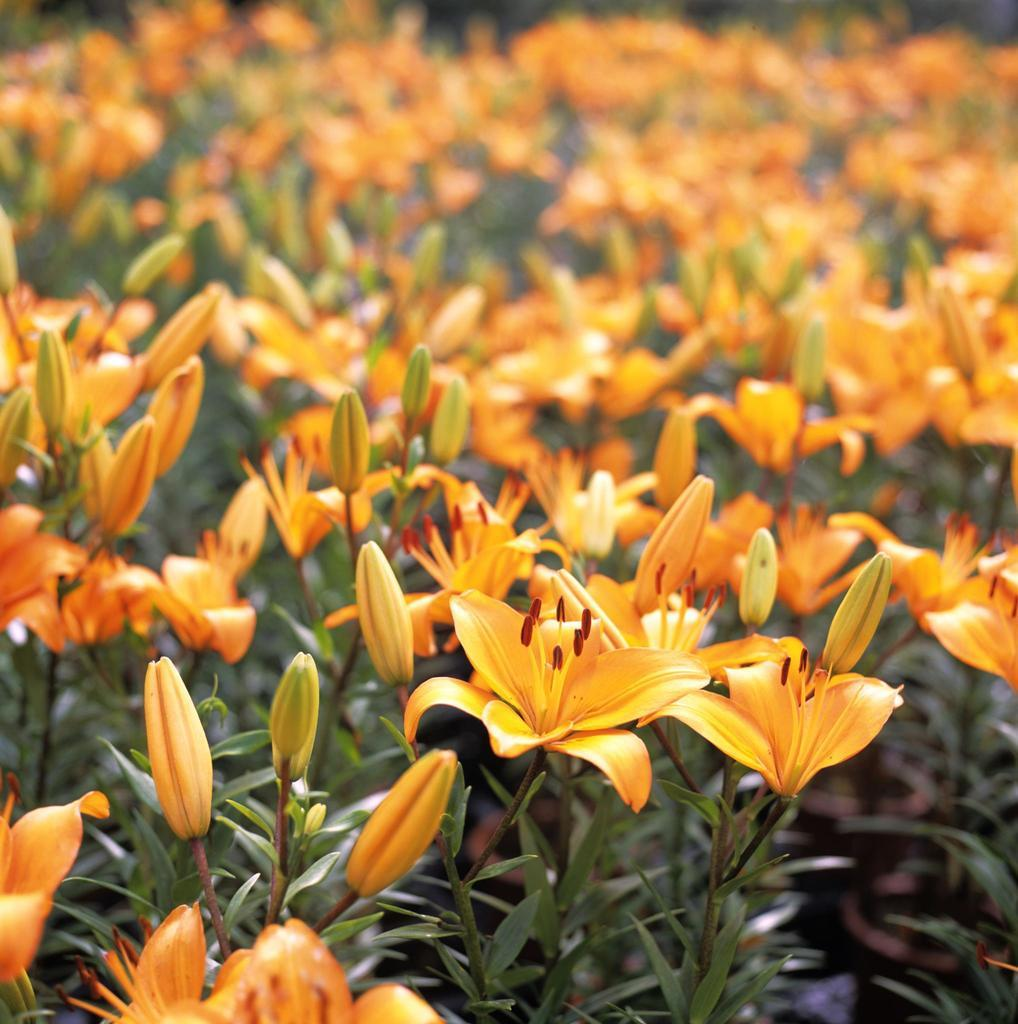What type of flowers can be seen in the image? There are orange color flowers in the image. What stage of growth are some of the flowers in? There are buds in the image. What else is present in the image besides flowers? There are plants in the image. How would you describe the background of the image? The background of the image is slightly blurry. What type of tools does the carpenter use in the image? There is no carpenter present in the image, so it is not possible to determine what tools they might use. 